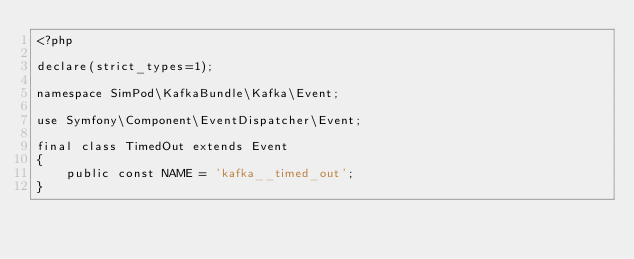<code> <loc_0><loc_0><loc_500><loc_500><_PHP_><?php

declare(strict_types=1);

namespace SimPod\KafkaBundle\Kafka\Event;

use Symfony\Component\EventDispatcher\Event;

final class TimedOut extends Event
{
    public const NAME = 'kafka__timed_out';
}
</code> 